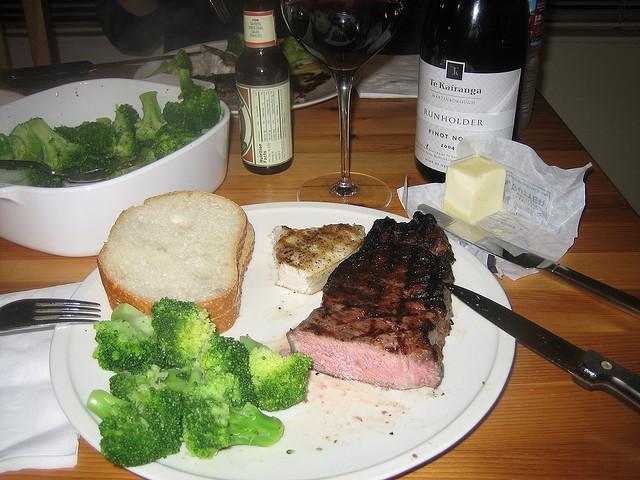How is this steak cooked?
Answer the question by selecting the correct answer among the 4 following choices and explain your choice with a short sentence. The answer should be formatted with the following format: `Answer: choice
Rationale: rationale.`
Options: Rare, medium, well done, blue rare. Answer: medium.
Rationale: There is some pink showing. 